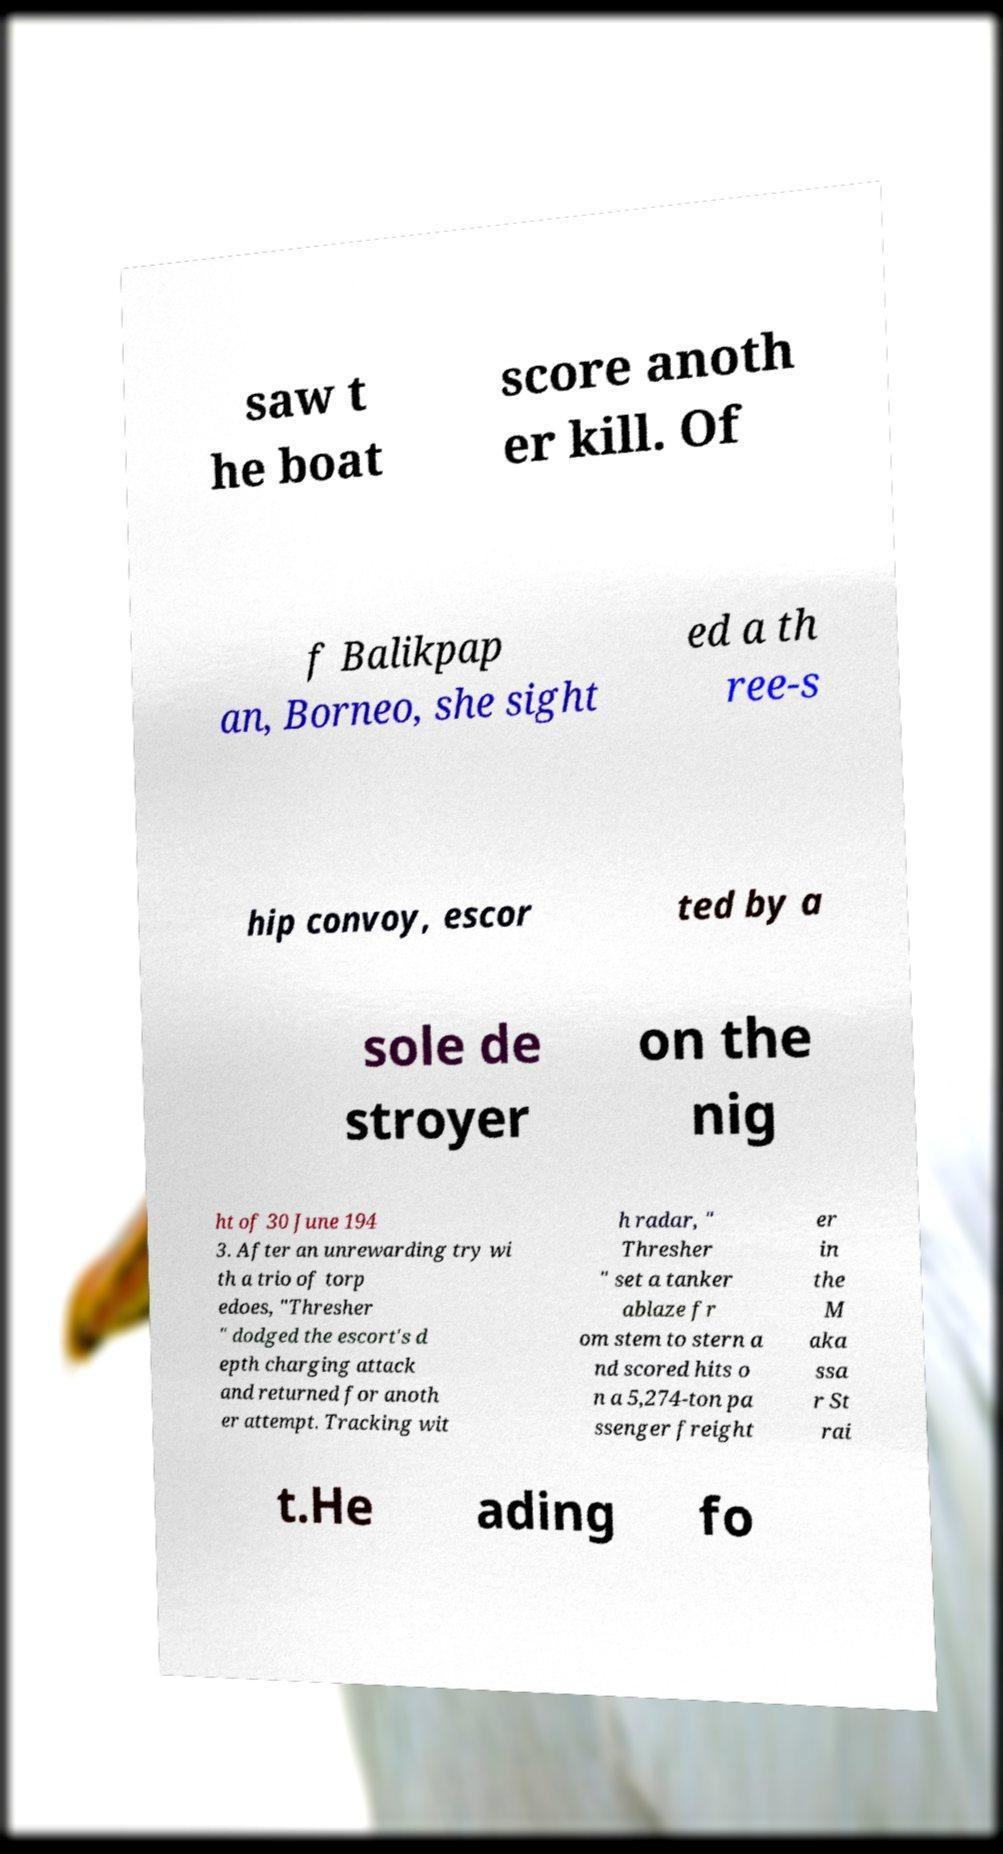What messages or text are displayed in this image? I need them in a readable, typed format. saw t he boat score anoth er kill. Of f Balikpap an, Borneo, she sight ed a th ree-s hip convoy, escor ted by a sole de stroyer on the nig ht of 30 June 194 3. After an unrewarding try wi th a trio of torp edoes, "Thresher " dodged the escort's d epth charging attack and returned for anoth er attempt. Tracking wit h radar, " Thresher " set a tanker ablaze fr om stem to stern a nd scored hits o n a 5,274-ton pa ssenger freight er in the M aka ssa r St rai t.He ading fo 